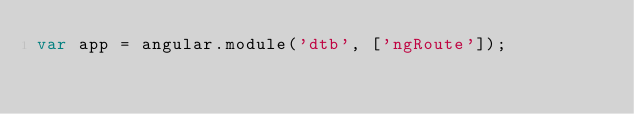Convert code to text. <code><loc_0><loc_0><loc_500><loc_500><_JavaScript_>var app = angular.module('dtb', ['ngRoute']);</code> 